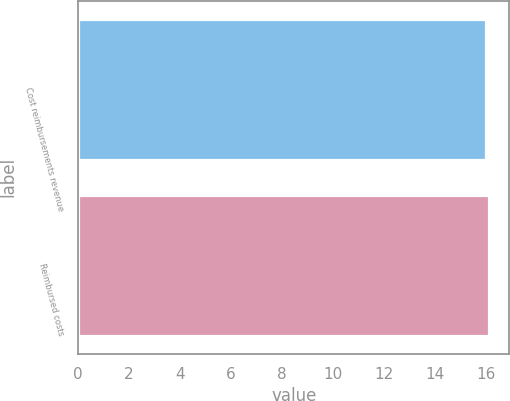Convert chart. <chart><loc_0><loc_0><loc_500><loc_500><bar_chart><fcel>Cost reimbursements revenue<fcel>Reimbursed costs<nl><fcel>16<fcel>16.1<nl></chart> 